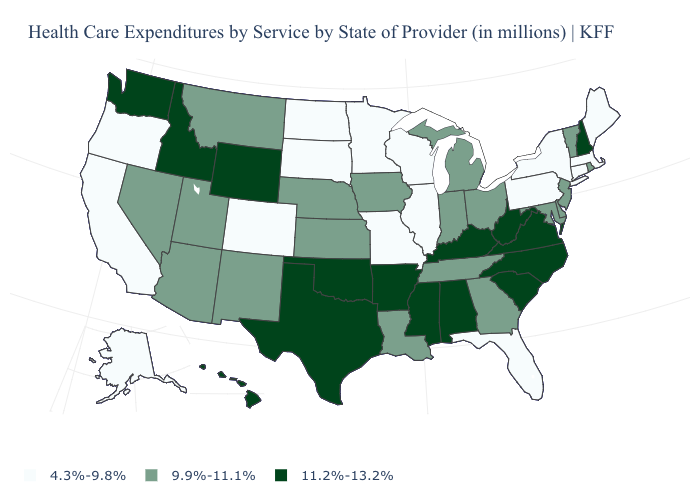How many symbols are there in the legend?
Quick response, please. 3. What is the value of Washington?
Give a very brief answer. 11.2%-13.2%. Which states have the highest value in the USA?
Answer briefly. Alabama, Arkansas, Hawaii, Idaho, Kentucky, Mississippi, New Hampshire, North Carolina, Oklahoma, South Carolina, Texas, Virginia, Washington, West Virginia, Wyoming. Does Montana have the lowest value in the West?
Quick response, please. No. What is the highest value in the West ?
Keep it brief. 11.2%-13.2%. Among the states that border Nevada , which have the highest value?
Concise answer only. Idaho. What is the highest value in the USA?
Write a very short answer. 11.2%-13.2%. Does Kansas have the highest value in the MidWest?
Be succinct. Yes. Does Iowa have the same value as Georgia?
Quick response, please. Yes. What is the value of Alabama?
Answer briefly. 11.2%-13.2%. Does the first symbol in the legend represent the smallest category?
Keep it brief. Yes. Name the states that have a value in the range 4.3%-9.8%?
Quick response, please. Alaska, California, Colorado, Connecticut, Florida, Illinois, Maine, Massachusetts, Minnesota, Missouri, New York, North Dakota, Oregon, Pennsylvania, South Dakota, Wisconsin. What is the lowest value in the USA?
Concise answer only. 4.3%-9.8%. What is the value of Montana?
Quick response, please. 9.9%-11.1%. 